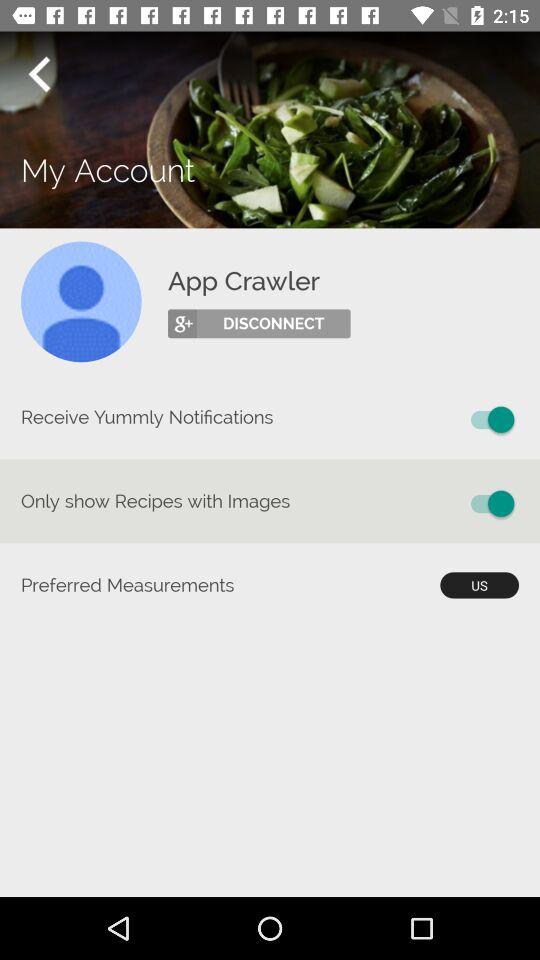What is the username? The username is App Crawler. 